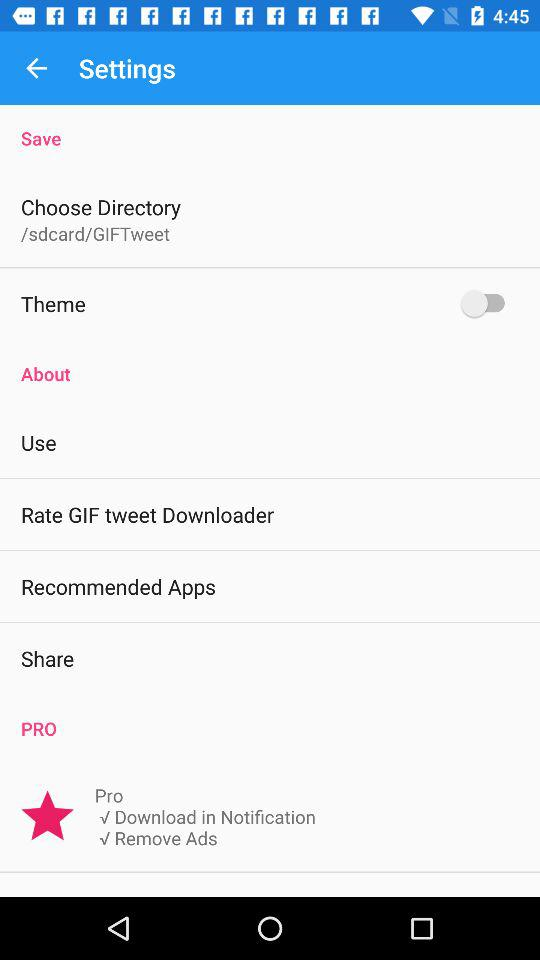Which apps are recommended?
When the provided information is insufficient, respond with <no answer>. <no answer> 